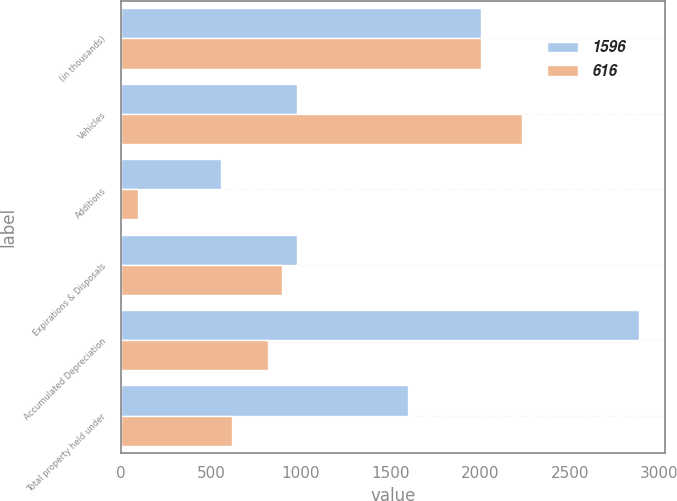<chart> <loc_0><loc_0><loc_500><loc_500><stacked_bar_chart><ecel><fcel>(in thousands)<fcel>Vehicles<fcel>Additions<fcel>Expirations & Disposals<fcel>Accumulated Depreciation<fcel>Total property held under<nl><fcel>1596<fcel>2007<fcel>979<fcel>559<fcel>979<fcel>2888<fcel>1596<nl><fcel>616<fcel>2006<fcel>2234<fcel>92<fcel>898<fcel>819<fcel>616<nl></chart> 